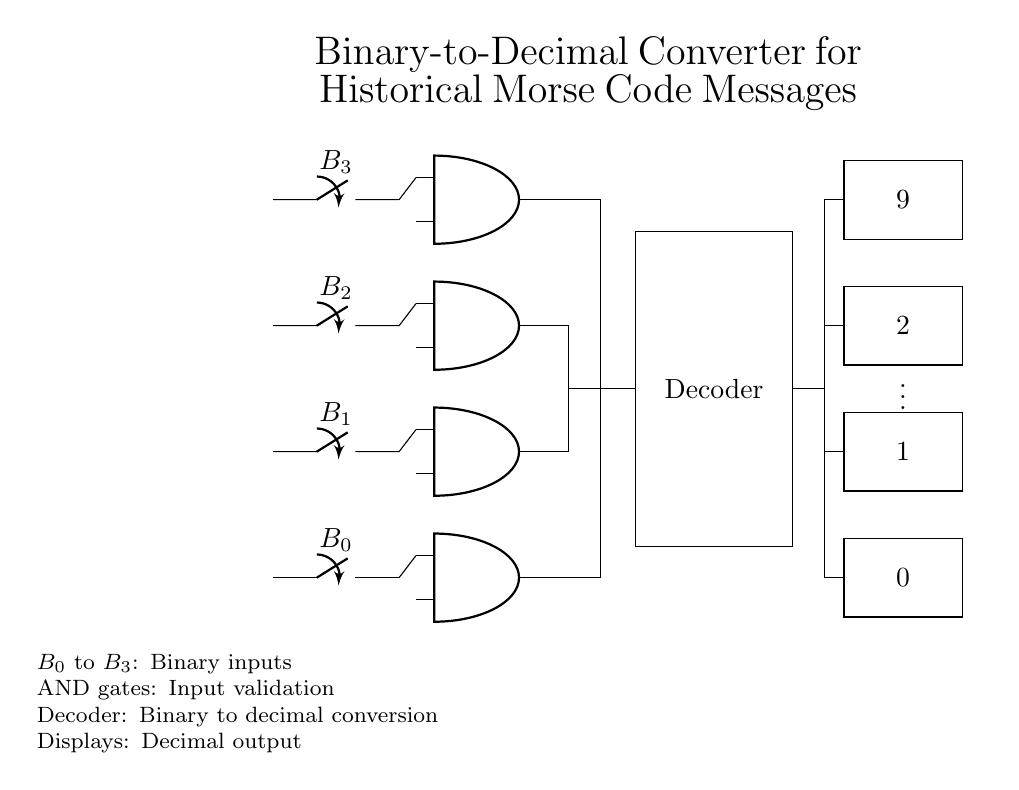what are the binary inputs in this circuit? The binary inputs in the circuit are labeled as B0, B1, B2, and B3. They are represented as switches located on the left side of the diagram.
Answer: B0, B1, B2, B3 how many AND gates are present in the circuit? There are four AND gates shown in the circuit, each positioned vertically to process the binary inputs separately.
Answer: 4 what is the function of the decoder in this circuit? The decoder takes the binary inputs from the AND gates and transforms them into their corresponding decimal representation displayed on the output.
Answer: Decimal conversion what are the outputs displayed in the circuit? The outputs are shown in the rectangles near the right side, labeled 0, 1, 2, and 9, indicating the decimal values corresponding to the binary inputs.
Answer: 0, 1, 2, 9 which logic gates are used for input validation? The circuit utilizes AND gates as the logic gates responsible for validating the state of the binary inputs before sending the signals to the decoder.
Answer: AND gates how does the binary number influence the output on the display? The binary combination of inputs B0 to B3 determines which output line is activated in the decoder, directly corresponding to a decimal number represented by those inputs.
Answer: Active outputs what determines the connection from the AND gates to the decoder? The connections from the AND gates to the decoder are determined by the output states of the AND gates, which align with the binary input conditions necessary for the decoder to function properly.
Answer: Output states 